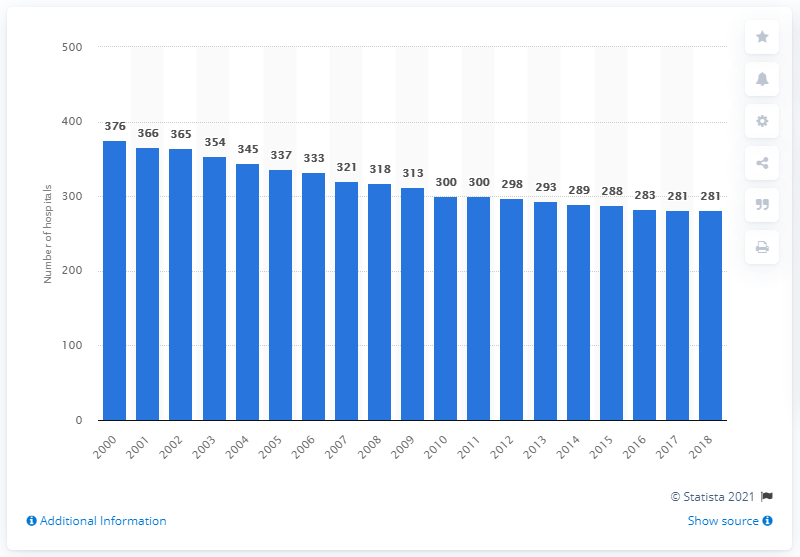Outline some significant characteristics in this image. There were 281 hospitals in Switzerland in 2018. Since the year 2000, the number of hospitals in Switzerland has declined. 